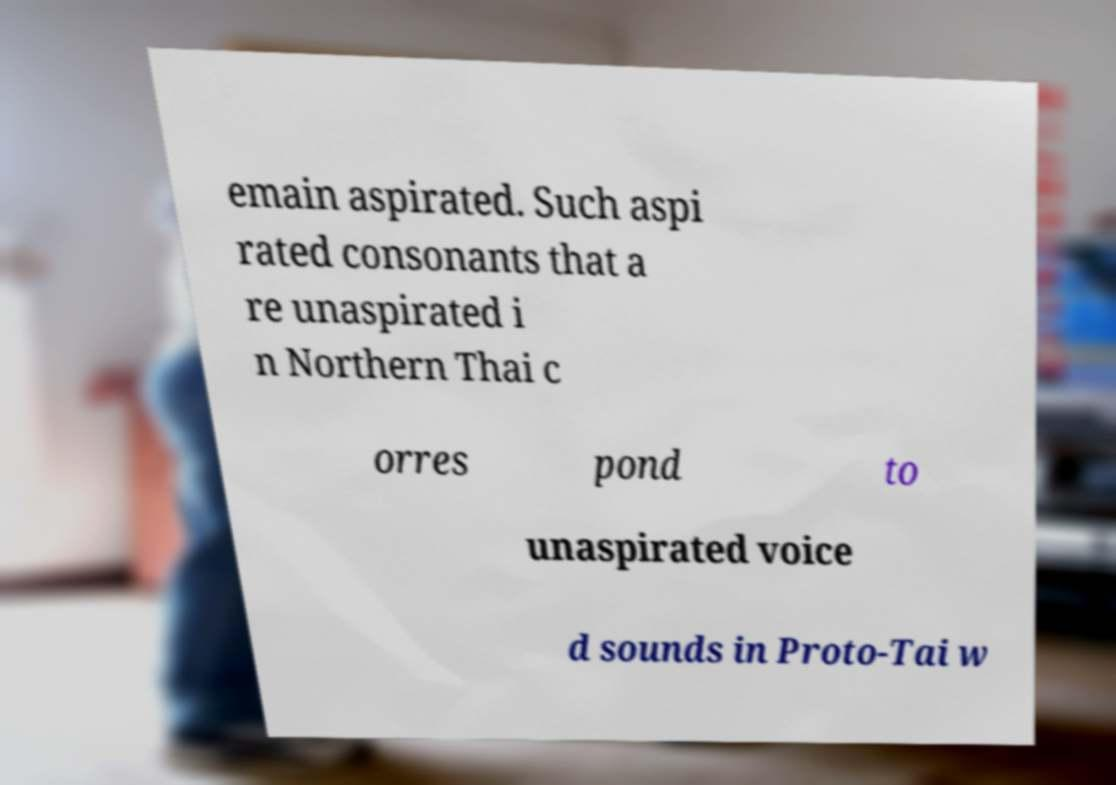Can you accurately transcribe the text from the provided image for me? emain aspirated. Such aspi rated consonants that a re unaspirated i n Northern Thai c orres pond to unaspirated voice d sounds in Proto-Tai w 